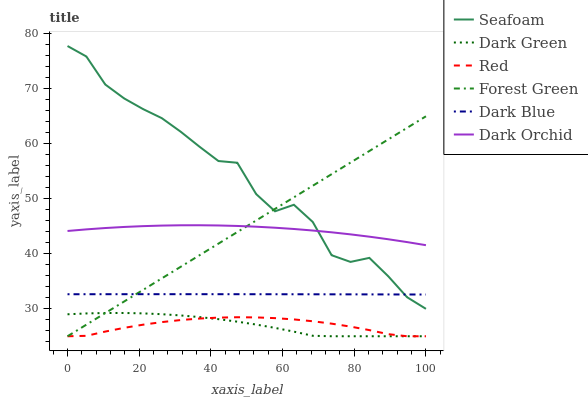Does Red have the minimum area under the curve?
Answer yes or no. Yes. Does Dark Orchid have the minimum area under the curve?
Answer yes or no. No. Does Dark Orchid have the maximum area under the curve?
Answer yes or no. No. Is Seafoam the roughest?
Answer yes or no. Yes. Is Dark Orchid the smoothest?
Answer yes or no. No. Is Dark Orchid the roughest?
Answer yes or no. No. Does Dark Blue have the lowest value?
Answer yes or no. No. Does Dark Orchid have the highest value?
Answer yes or no. No. Is Red less than Seafoam?
Answer yes or no. Yes. Is Dark Blue greater than Red?
Answer yes or no. Yes. Does Red intersect Seafoam?
Answer yes or no. No. 